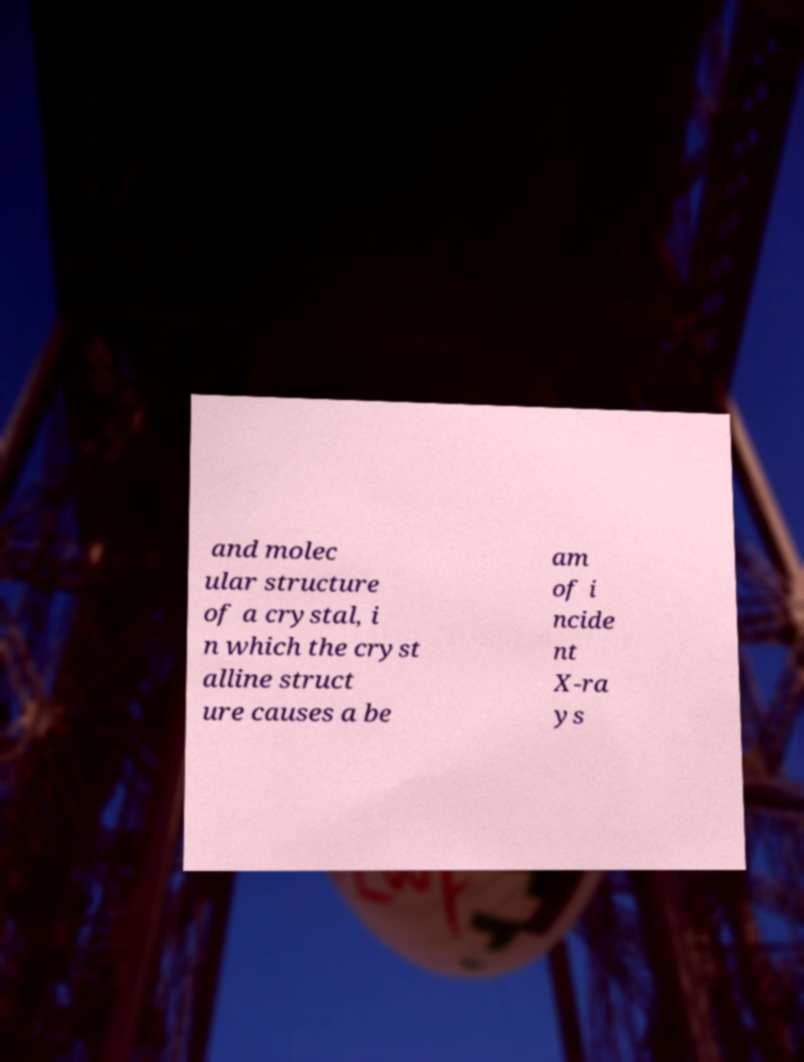Could you assist in decoding the text presented in this image and type it out clearly? and molec ular structure of a crystal, i n which the cryst alline struct ure causes a be am of i ncide nt X-ra ys 